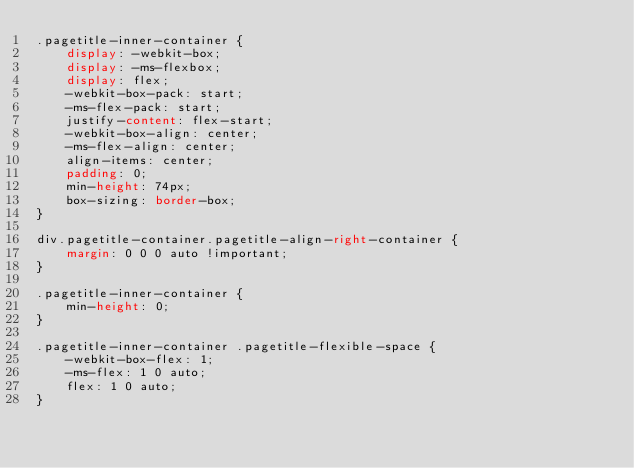<code> <loc_0><loc_0><loc_500><loc_500><_CSS_>.pagetitle-inner-container {
	display: -webkit-box;
	display: -ms-flexbox;
	display: flex;
	-webkit-box-pack: start;
	-ms-flex-pack: start;
	justify-content: flex-start;
	-webkit-box-align: center;
	-ms-flex-align: center;
	align-items: center;
	padding: 0;
	min-height: 74px;
	box-sizing: border-box;
}

div.pagetitle-container.pagetitle-align-right-container {
	margin: 0 0 0 auto !important;
}

.pagetitle-inner-container {
	min-height: 0;
}

.pagetitle-inner-container .pagetitle-flexible-space {
	-webkit-box-flex: 1;
	-ms-flex: 1 0 auto;
	flex: 1 0 auto;
}</code> 